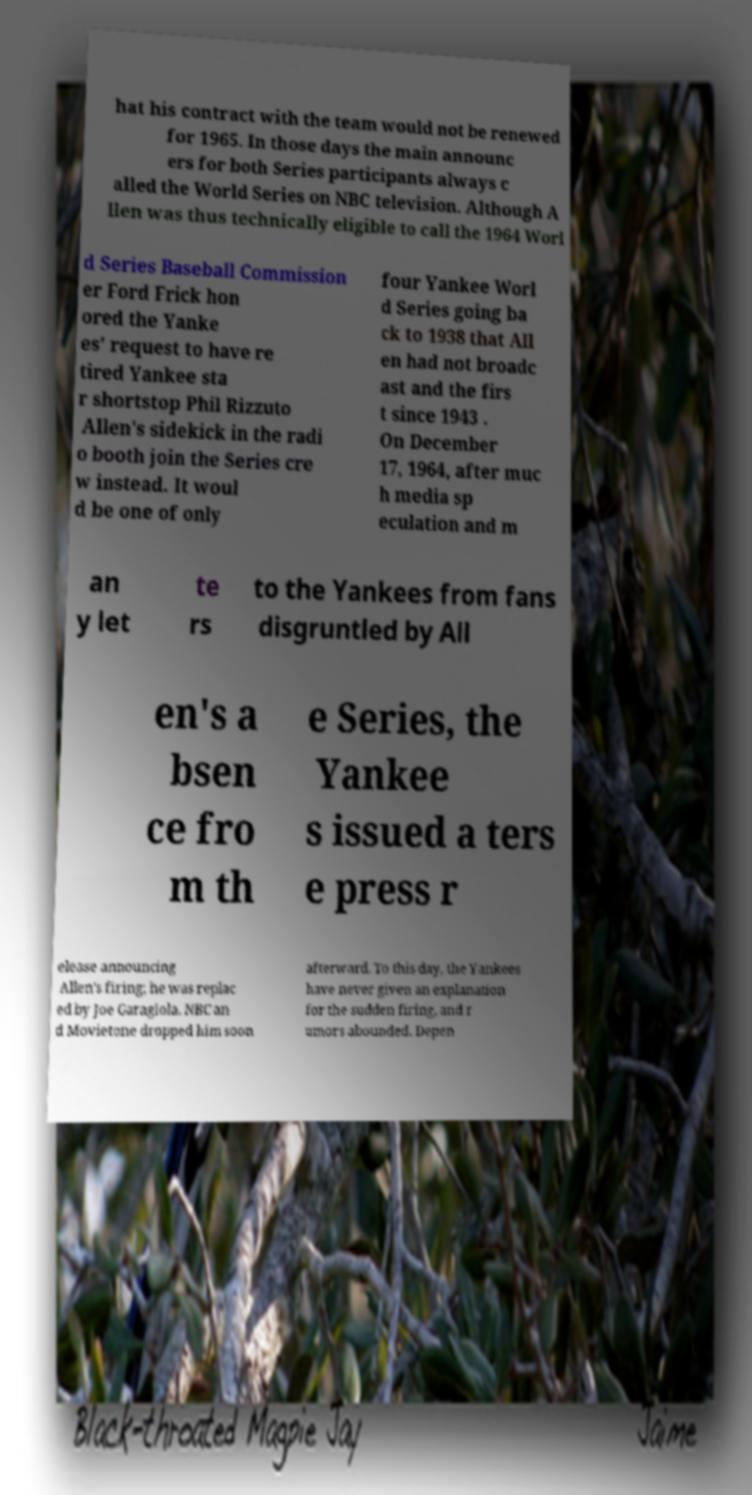What messages or text are displayed in this image? I need them in a readable, typed format. hat his contract with the team would not be renewed for 1965. In those days the main announc ers for both Series participants always c alled the World Series on NBC television. Although A llen was thus technically eligible to call the 1964 Worl d Series Baseball Commission er Ford Frick hon ored the Yanke es' request to have re tired Yankee sta r shortstop Phil Rizzuto Allen's sidekick in the radi o booth join the Series cre w instead. It woul d be one of only four Yankee Worl d Series going ba ck to 1938 that All en had not broadc ast and the firs t since 1943 . On December 17, 1964, after muc h media sp eculation and m an y let te rs to the Yankees from fans disgruntled by All en's a bsen ce fro m th e Series, the Yankee s issued a ters e press r elease announcing Allen's firing; he was replac ed by Joe Garagiola. NBC an d Movietone dropped him soon afterward. To this day, the Yankees have never given an explanation for the sudden firing, and r umors abounded. Depen 